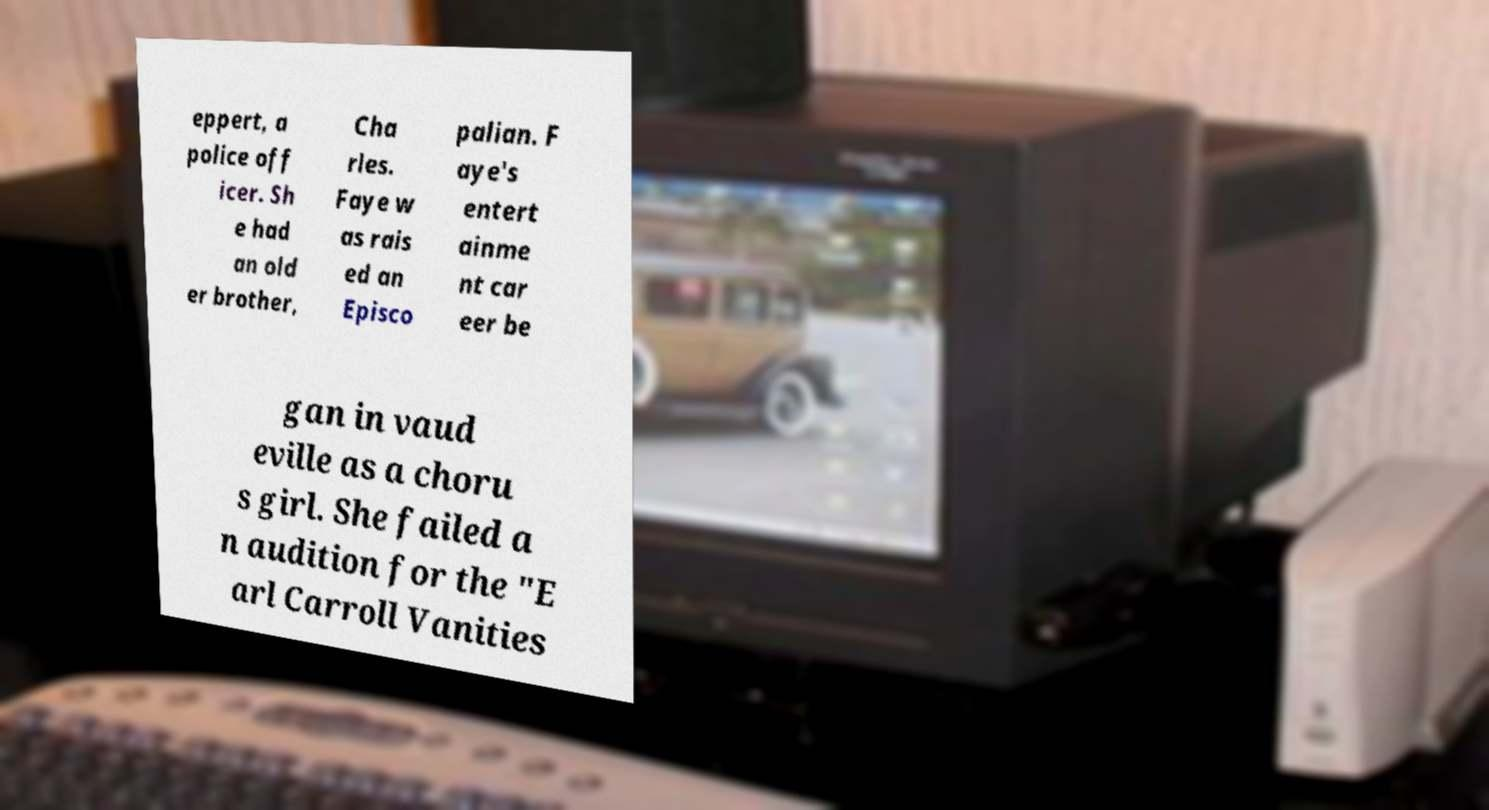Can you read and provide the text displayed in the image?This photo seems to have some interesting text. Can you extract and type it out for me? eppert, a police off icer. Sh e had an old er brother, Cha rles. Faye w as rais ed an Episco palian. F aye's entert ainme nt car eer be gan in vaud eville as a choru s girl. She failed a n audition for the "E arl Carroll Vanities 